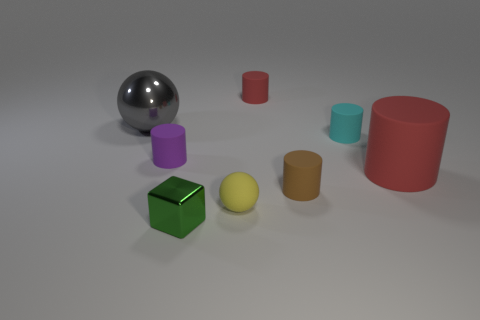Subtract 1 cylinders. How many cylinders are left? 4 Subtract all brown cylinders. How many cylinders are left? 4 Subtract all brown cylinders. How many cylinders are left? 4 Add 1 cubes. How many objects exist? 9 Subtract all gray cylinders. Subtract all blue blocks. How many cylinders are left? 5 Subtract all cubes. How many objects are left? 7 Add 5 small blocks. How many small blocks are left? 6 Add 3 small green metallic balls. How many small green metallic balls exist? 3 Subtract 0 red blocks. How many objects are left? 8 Subtract all gray blocks. Subtract all cyan cylinders. How many objects are left? 7 